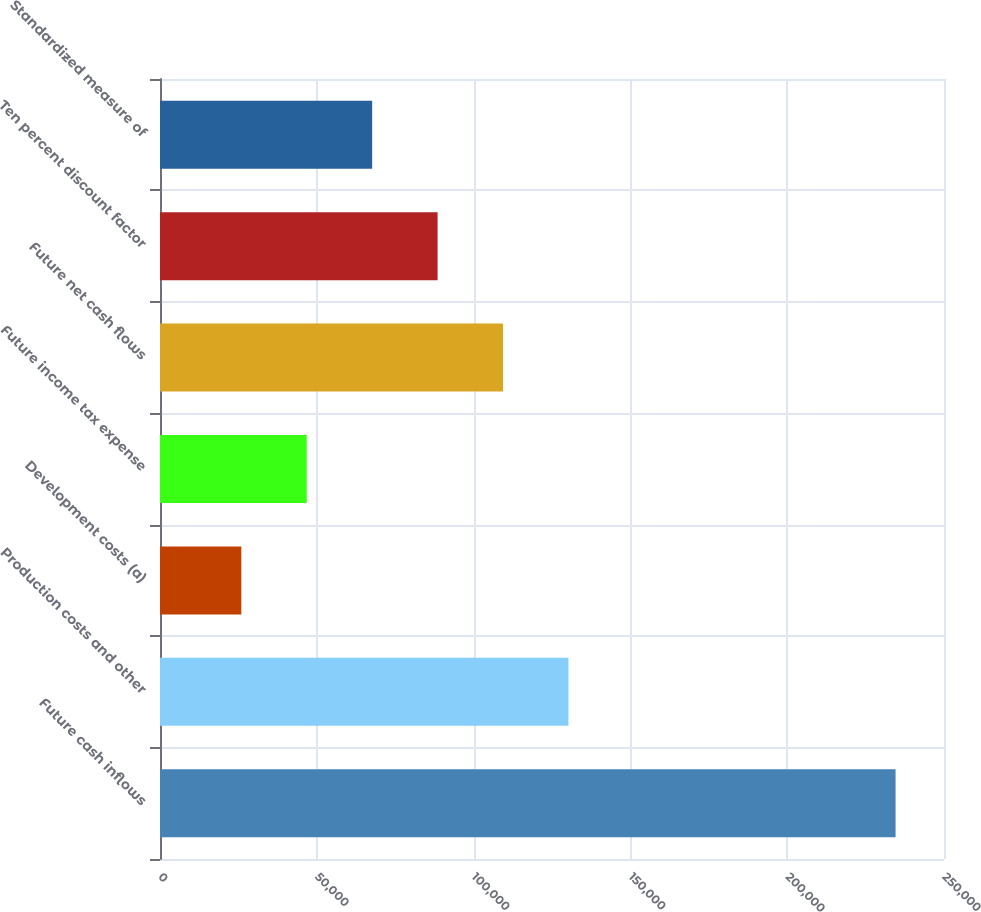Convert chart to OTSL. <chart><loc_0><loc_0><loc_500><loc_500><bar_chart><fcel>Future cash inflows<fcel>Production costs and other<fcel>Development costs (a)<fcel>Future income tax expense<fcel>Future net cash flows<fcel>Ten percent discount factor<fcel>Standardized measure of<nl><fcel>234558<fcel>130242<fcel>25926<fcel>46789.2<fcel>109379<fcel>88515.6<fcel>67652.4<nl></chart> 